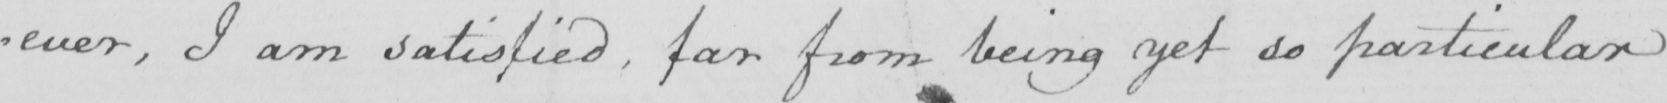Can you tell me what this handwritten text says? -ever I am satisfied , far from being yet so particular 